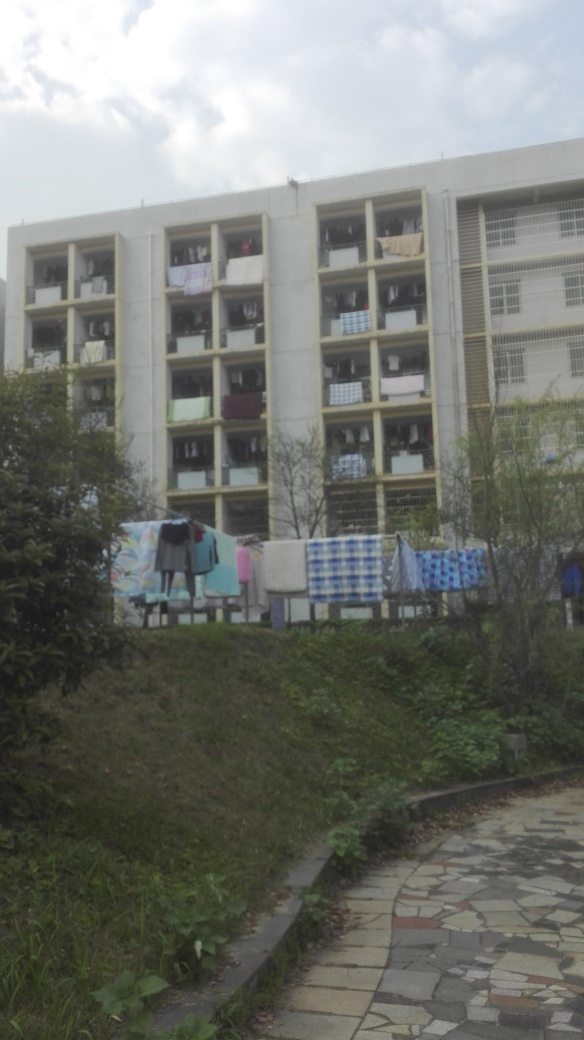Is there any indication of the season or weather at the time this photo was taken? The presence of green foliage suggests it's not winter, and the clothes hung out to dry imply it's a dry day, likely in a warmer season like spring or summer. 